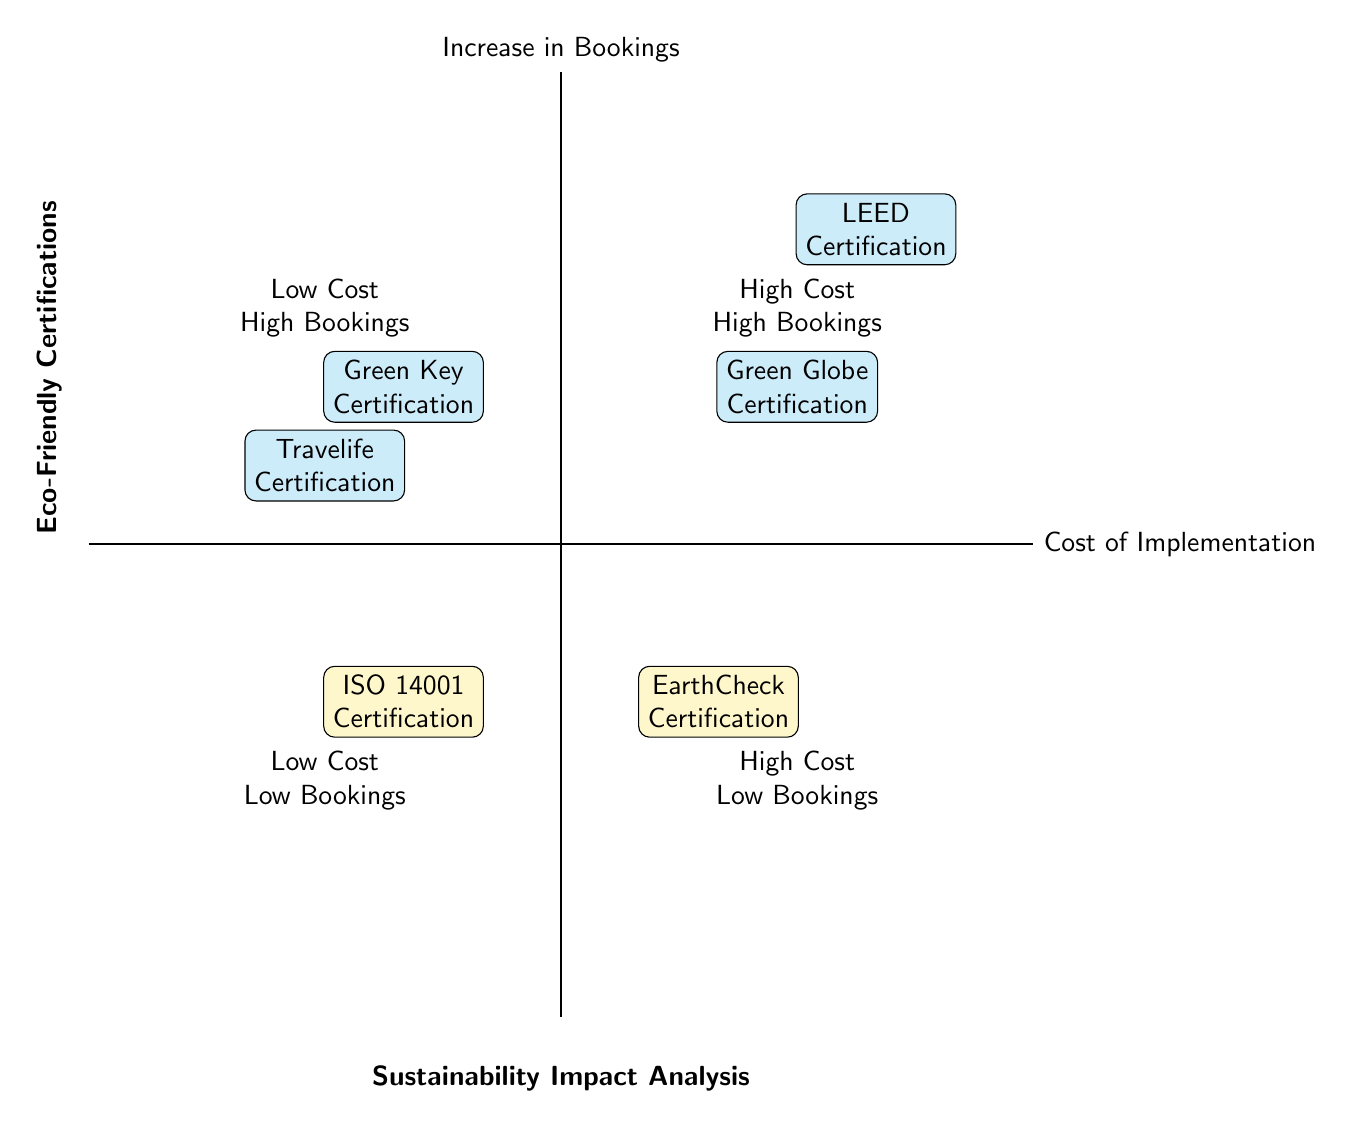What certifications fall into the High Cost High Bookings quadrant? In the High Cost High Bookings quadrant, we have two certifications listed: LEED Certification and Green Globe Certification.
Answer: LEED Certification, Green Globe Certification How many certifications are in the Low Cost Low Bookings quadrant? The Low Cost Low Bookings quadrant contains only one certification, which is ISO 14001 Certification.
Answer: 1 Which certification has the highest potential increase in bookings? The certification with the highest potential increase in bookings, as shown in the diagram, is LEED Certification, with an expected increase of 25% - 30%.
Answer: LEED Certification What is the cost range for EarthCheck Certification? The cost range for EarthCheck Certification is between $15,000 and $50,000. This is clearly indicated in the diagram under the High Cost Low Bookings quadrant.
Answer: $15,000 - $50,000 Which quadrant contains the Green Key Certification? Green Key Certification is located in the Low Cost High Bookings quadrant, as indicated in the diagram.
Answer: Low Cost High Bookings What is the expected increase in bookings for ISO 14001 Certification? The expected increase in bookings for ISO 14001 Certification is between 5% and 10%, as shown in the diagram in the Low Cost Low Bookings quadrant.
Answer: 5% - 10% Which certifications are expected to increase bookings by more than 20%? The certifications expected to increase bookings by more than 20% are LEED Certification and Green Globe Certification, both falling under the High Cost High Bookings quadrant.
Answer: LEED Certification, Green Globe Certification How does the cost of Travelife Certification compare to Green Key Certification? Travelife Certification, which ranges from $1,000 to $2,000, is lower in cost compared to Green Key Certification, which ranges from $3,000 to $6,000. Thus, Green Key Certification has a higher implementation cost.
Answer: Green Key Certification costs more 